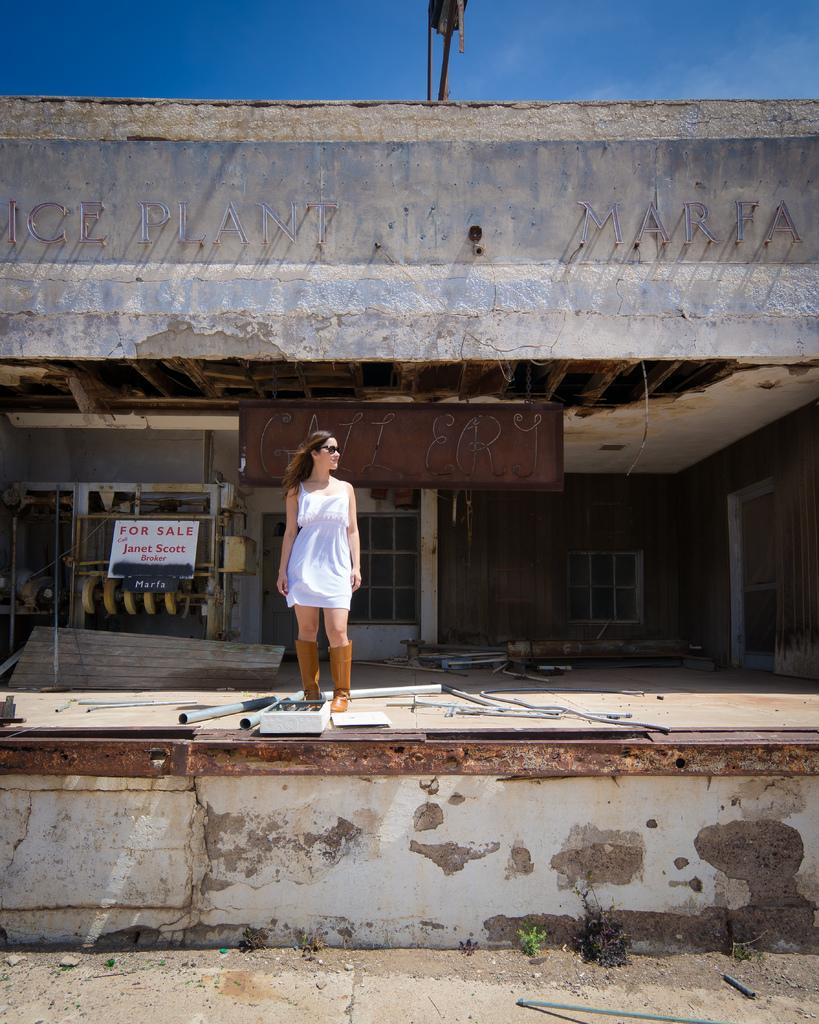What is the main subject in the image? There is a woman standing in the image. What can be seen behind the woman? There is a wall in the image. What are the rods used for in the image? The purpose of the rods is not specified, but they are visible in the image. What is on the surface in the image? There are objects on the surface in the image. What is visible in the background of the image? There are boards and windows in the background of the image. What part of the natural environment is visible in the image? The sky is visible in the image. What type of flame can be seen coming from the police car in the image? There is no police car or flame present in the image. 